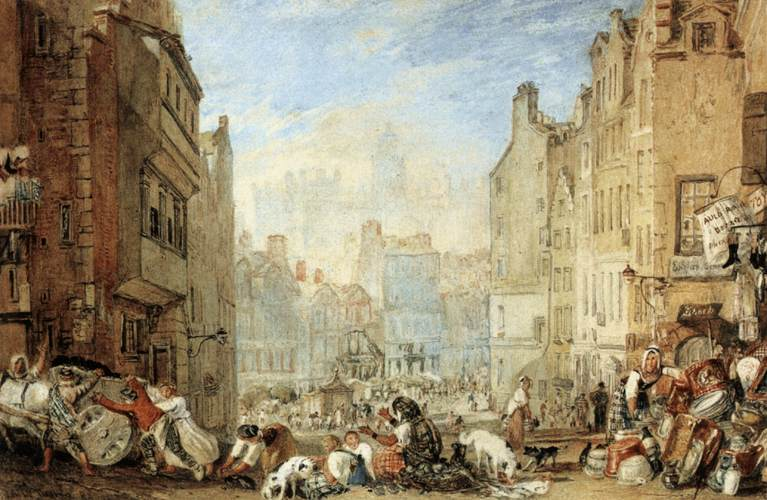Can you tell more about the social dynamics visible in this scene? Certainly! The scene vividly portrays a range of social interactions and classes. You can observe well-dressed individuals possibly from the upper class mingling or moving through the area, contrasting with others who appear to be working-class citizens engaging in trade or labor, such as street vendors and people tending to animals. The interaction between different social strata and the busy nature of the street highlight a complex social fabric, where various societal roles converge within the public sphere of the city. 